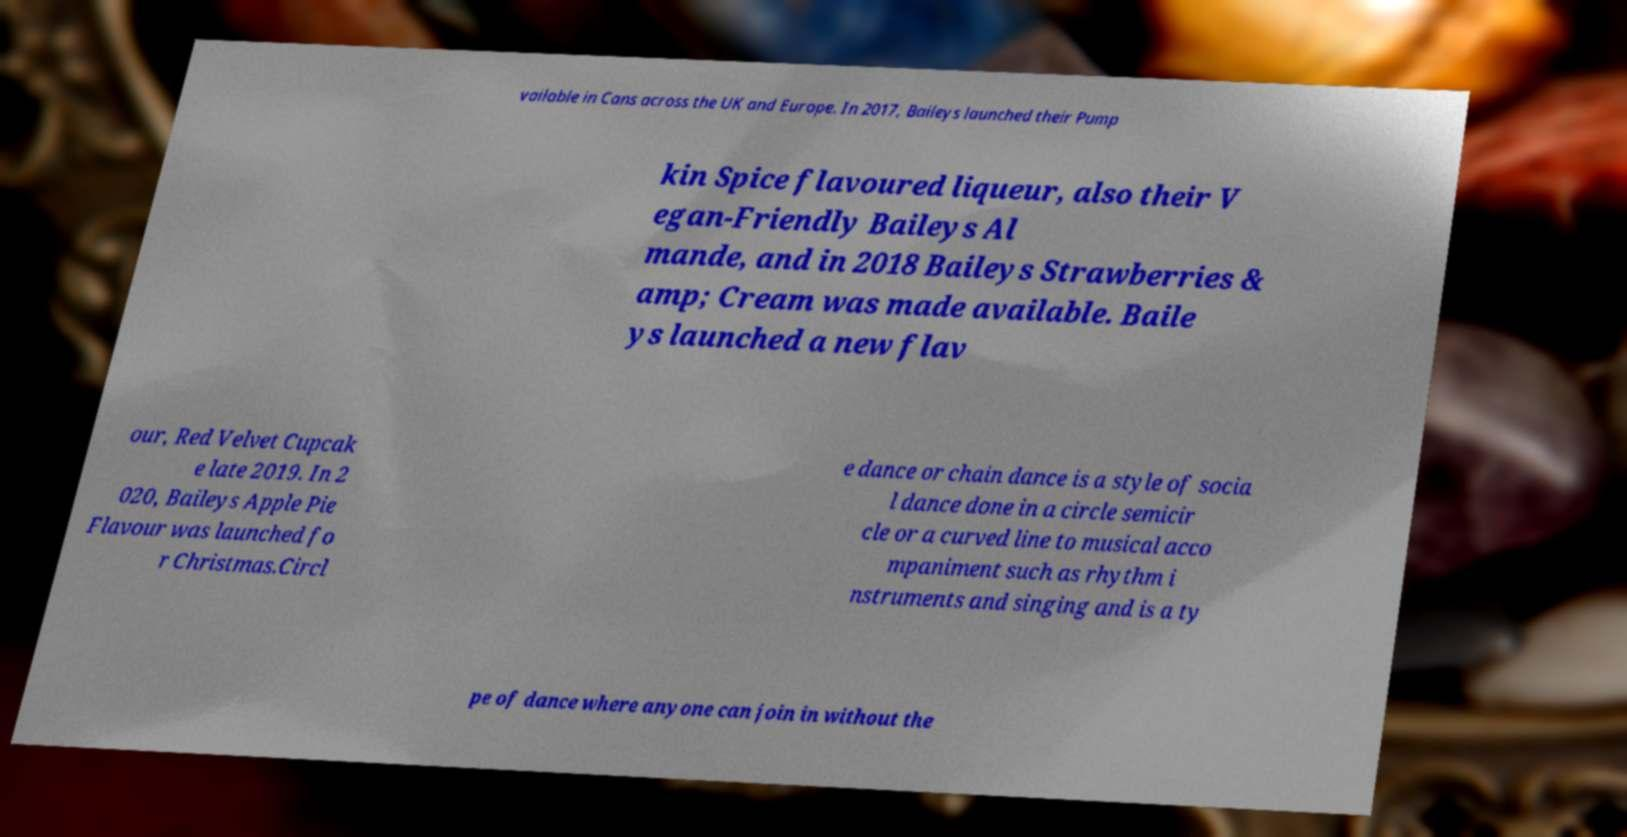I need the written content from this picture converted into text. Can you do that? vailable in Cans across the UK and Europe. In 2017, Baileys launched their Pump kin Spice flavoured liqueur, also their V egan-Friendly Baileys Al mande, and in 2018 Baileys Strawberries & amp; Cream was made available. Baile ys launched a new flav our, Red Velvet Cupcak e late 2019. In 2 020, Baileys Apple Pie Flavour was launched fo r Christmas.Circl e dance or chain dance is a style of socia l dance done in a circle semicir cle or a curved line to musical acco mpaniment such as rhythm i nstruments and singing and is a ty pe of dance where anyone can join in without the 